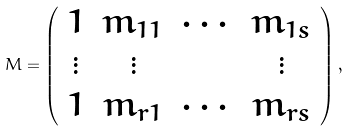<formula> <loc_0><loc_0><loc_500><loc_500>M = \left ( \begin{array} { c c c c } 1 & m _ { 1 1 } & \cdots & m _ { 1 s } \\ \vdots & \vdots & & \vdots \\ 1 & m _ { r 1 } & \cdots & m _ { r s } \\ \end{array} \right ) ,</formula> 